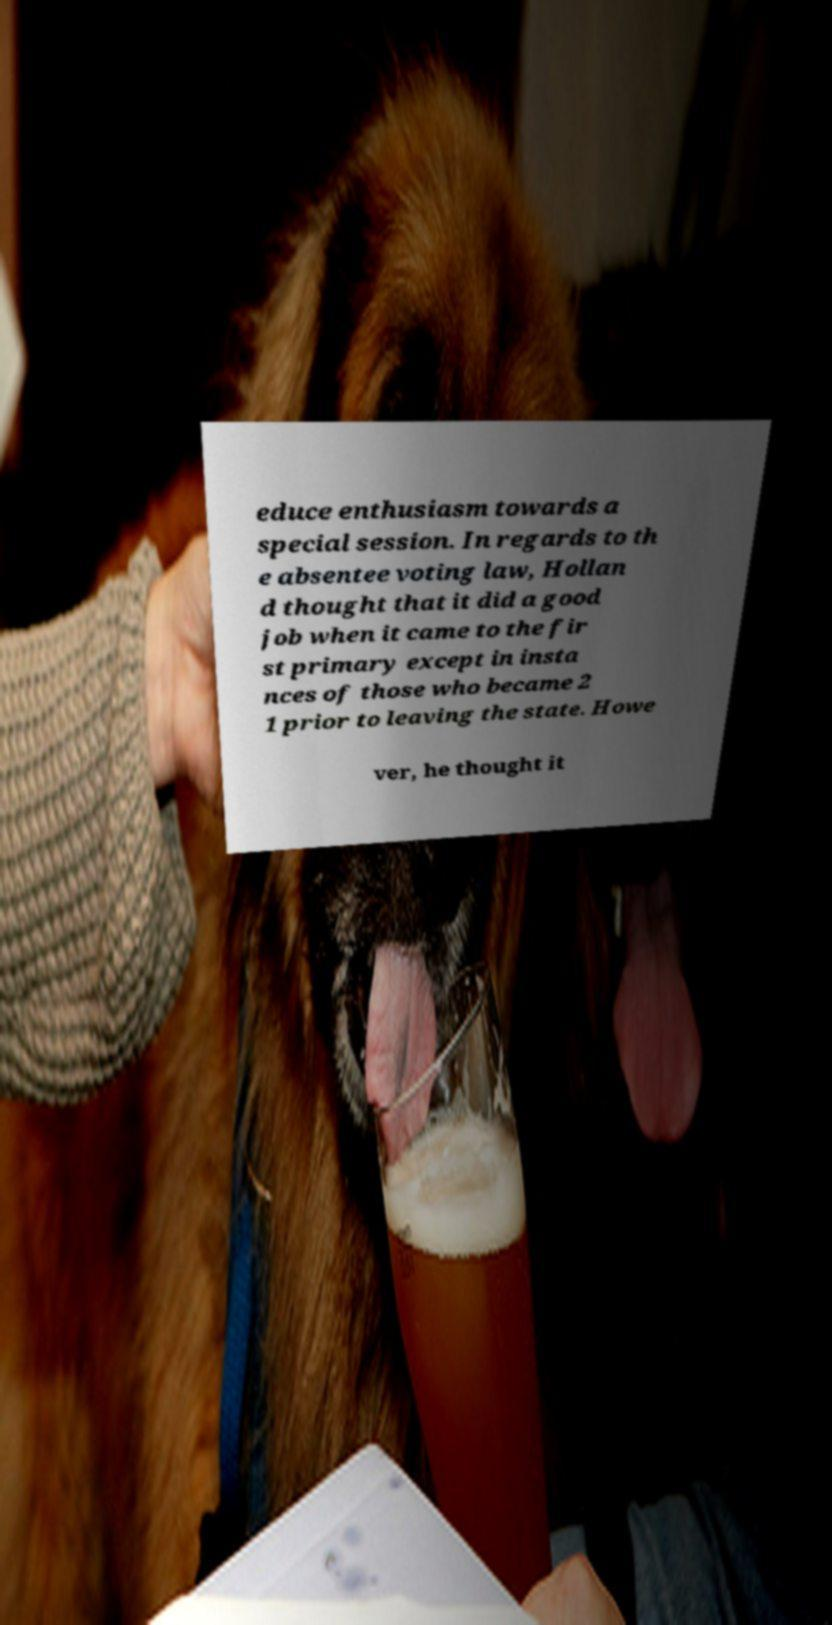Could you assist in decoding the text presented in this image and type it out clearly? educe enthusiasm towards a special session. In regards to th e absentee voting law, Hollan d thought that it did a good job when it came to the fir st primary except in insta nces of those who became 2 1 prior to leaving the state. Howe ver, he thought it 